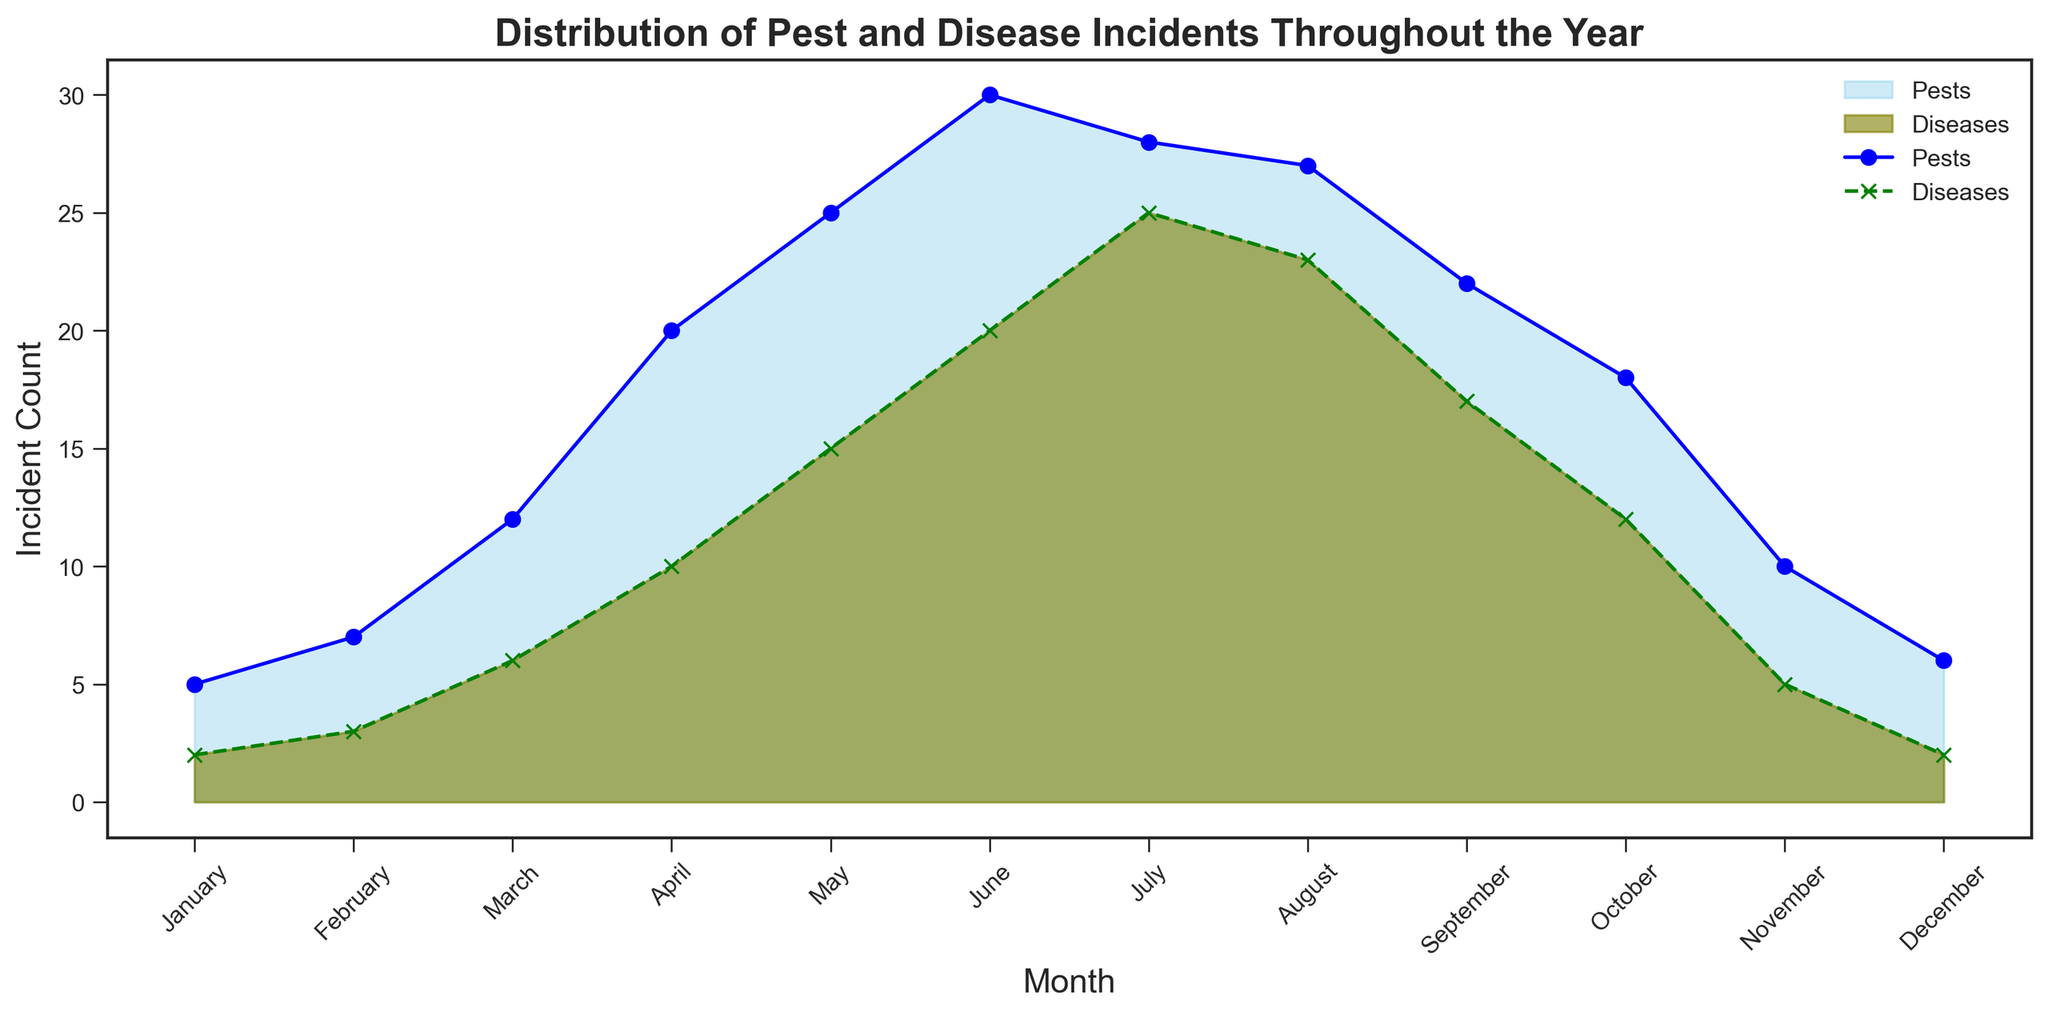What's the highest incident count of pests? From the plot, observe the peaks of the areas corresponding to pests. The highest point is in June with a count of 30.
Answer: 30 Which month has the highest number of disease incidents? From the plot, determine the month where the area representing diseases is at its maximum height. This occurs in July with a count of 25.
Answer: July How does the number of pest incidents in March compare to disease incidents in March? Observe the heights of the respective areas and points in March. Pests have a count of 12 and diseases have a count of 6.
Answer: Pests are higher What is the total number of pest and disease incidents in December? Add the incidents from both categories in December: 6 (pests) + 2 (diseases).
Answer: 8 Which month shows a decreasing trend in both pest and disease incidents compared to the previous month? Examine the plot for months where both pest and disease areas reduce. September to October shows a decrease in both pests (22 to 18) and diseases (17 to 12).
Answer: October Are there any months where pest incidents are lower than disease incidents? Scan across the plot and check for months where the area of pests is below diseases. July, August, and September show incidents where pests are lower than diseases.
Answer: Yes What are the total pest incidents for the first quarter (Jan-Mar)? Add the incidents for January, February, and March. 5 + 7 + 12 = 24.
Answer: 24 During which period of the year do pests show a rapid increase? Observe where the steepest rise in the pest's area occurs. This is from March to June.
Answer: March to June How does the trend of disease incidents change from April to November? Evaluate the general direction of the disease area. Disease incidents rise until July, then gradually decline until November.
Answer: Rise then fall What is the difference in incident count between pests in August and October? Subtract the count of pests in October (18) from August (27). 27 - 18 = 9.
Answer: 9 